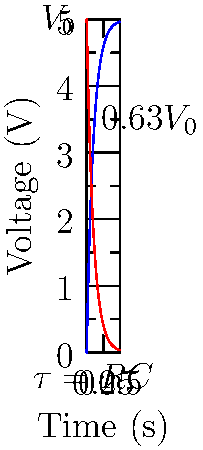In the beautiful region of Midi-Pyrénées, an RC circuit is used to control the timing of a light show for a local beauty pageant. The circuit has a resistance of 1 kΩ and a capacitance of 100 µF. If the applied voltage is 5V, how long will it take for the capacitor to charge to approximately 63% of its final voltage? To solve this problem, we need to follow these steps:

1. Recall that in an RC circuit, the time constant τ (tau) is given by the product of resistance R and capacitance C:
   
   $$ \tau = RC $$

2. Calculate the time constant using the given values:
   R = 1 kΩ = 1000 Ω
   C = 100 µF = 100 × 10^(-6) F
   
   $$ \tau = 1000 \times 100 \times 10^{-6} = 0.1 \text{ seconds} $$

3. In an RC charging circuit, the voltage across the capacitor at time t is given by:
   
   $$ V_C(t) = V_0(1 - e^{-t/\tau}) $$

   where V0 is the applied voltage.

4. The question asks for the time when the capacitor charges to 63% of its final voltage. This occurs when t = τ:
   
   $$ V_C(\tau) = V_0(1 - e^{-1}) \approx 0.63V_0 $$

5. Therefore, the time taken for the capacitor to charge to approximately 63% of its final voltage is equal to one time constant, τ.
Answer: 0.1 seconds 